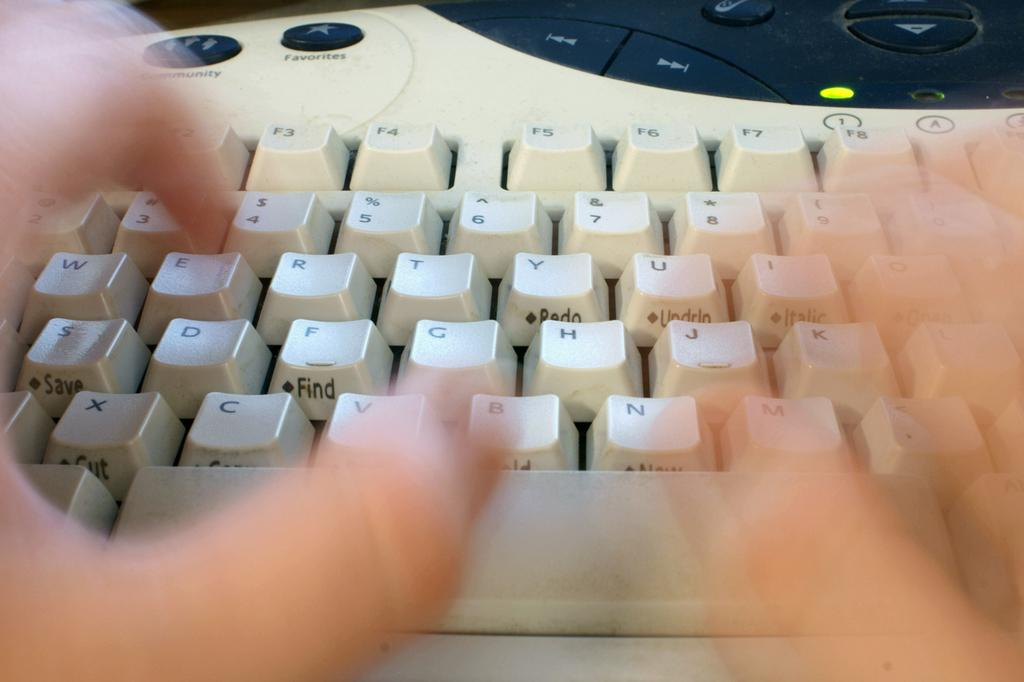Provide a one-sentence caption for the provided image. A keyboard featuring two blurry hands above alphabet keys and blue buttons that say "community"  and "favorites on the keyboard. 